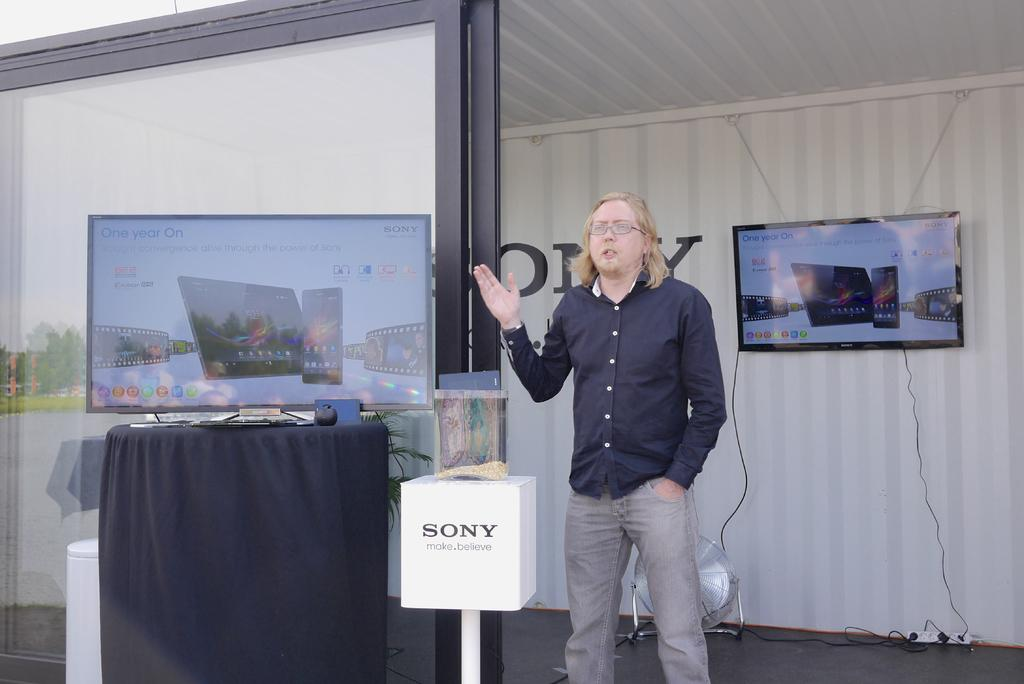<image>
Give a short and clear explanation of the subsequent image. A man in a black shirt stands near a small stand that says Sony on it. 